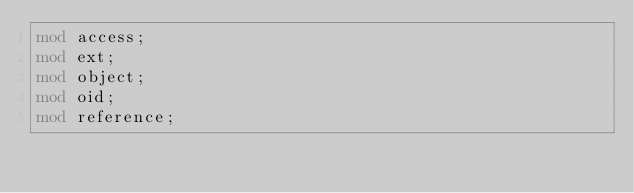<code> <loc_0><loc_0><loc_500><loc_500><_Rust_>mod access;
mod ext;
mod object;
mod oid;
mod reference;
</code> 